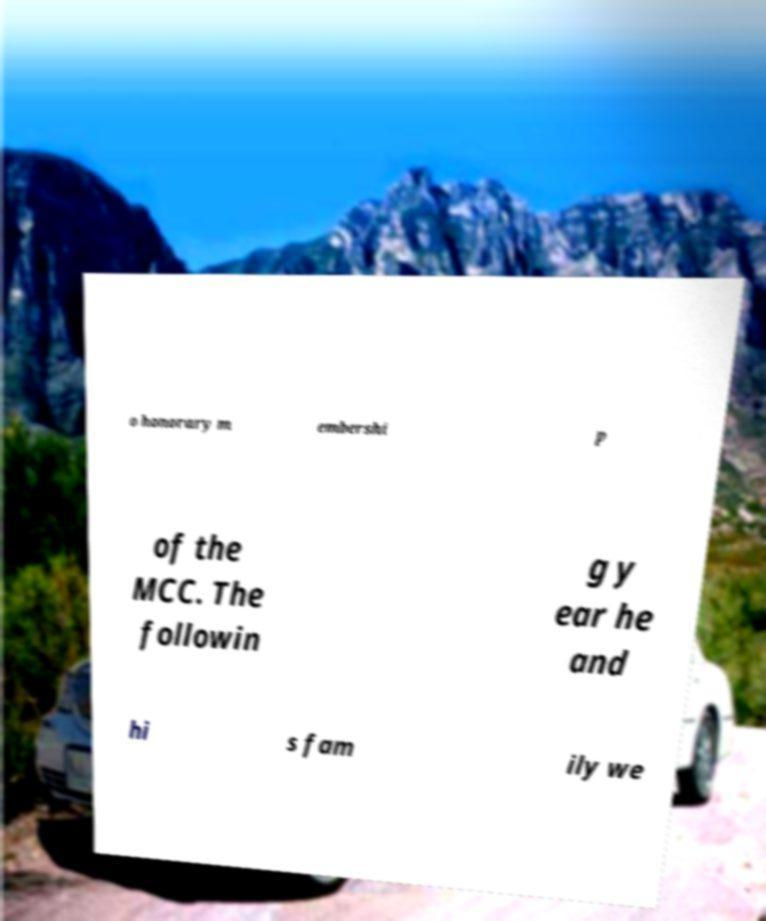What messages or text are displayed in this image? I need them in a readable, typed format. o honorary m embershi p of the MCC. The followin g y ear he and hi s fam ily we 